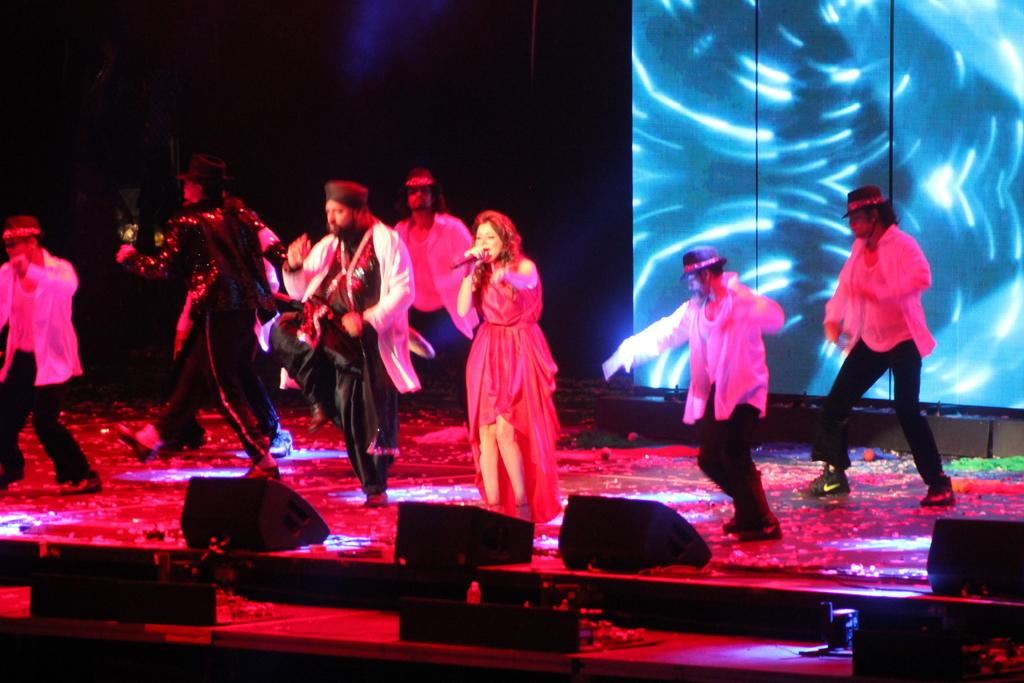What is happening in the image? There is a group of people in the image, and they are standing on a stage. Who is the central figure in the group? There is a woman in the middle of the group. What is the woman doing? The woman is singing on a microphone. What can be seen behind the group of people? There is a screen behind the group of people. What type of camp can be seen in the background of the image? There is no camp visible in the image; it features a group of people on a stage with a woman singing on a microphone and a screen behind them. 